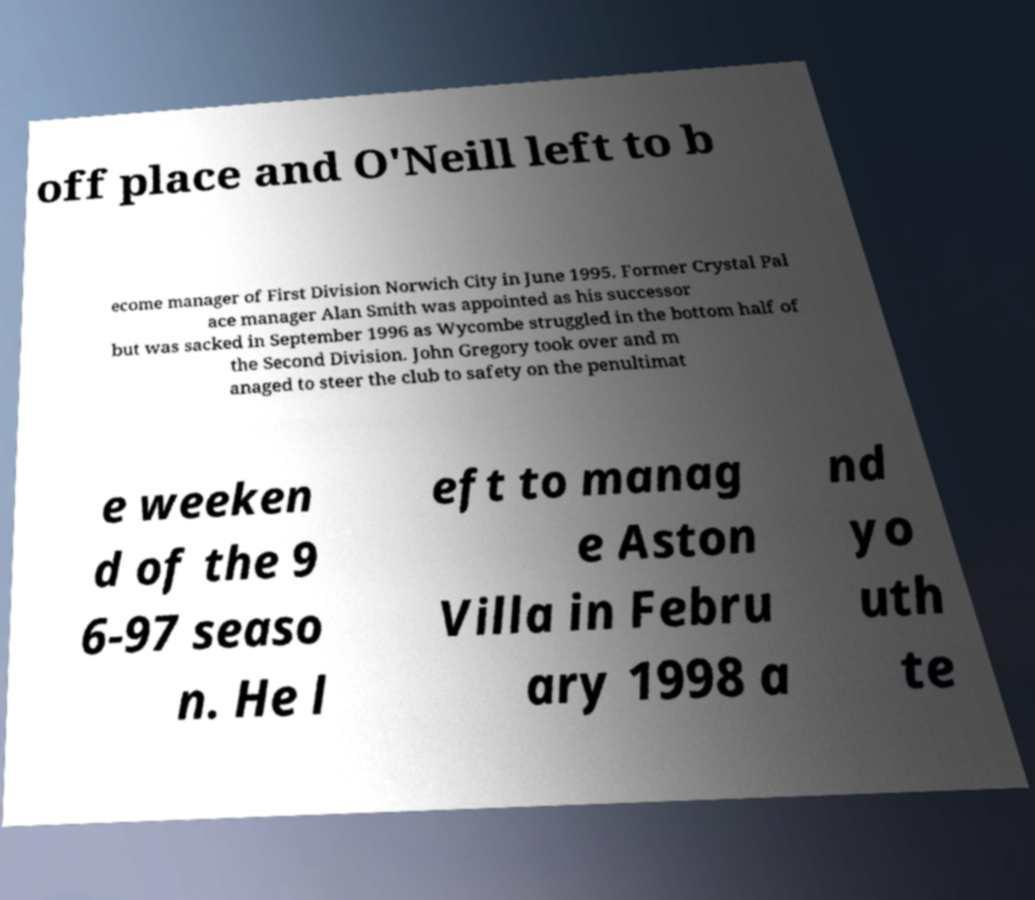Please read and relay the text visible in this image. What does it say? off place and O'Neill left to b ecome manager of First Division Norwich City in June 1995. Former Crystal Pal ace manager Alan Smith was appointed as his successor but was sacked in September 1996 as Wycombe struggled in the bottom half of the Second Division. John Gregory took over and m anaged to steer the club to safety on the penultimat e weeken d of the 9 6-97 seaso n. He l eft to manag e Aston Villa in Febru ary 1998 a nd yo uth te 